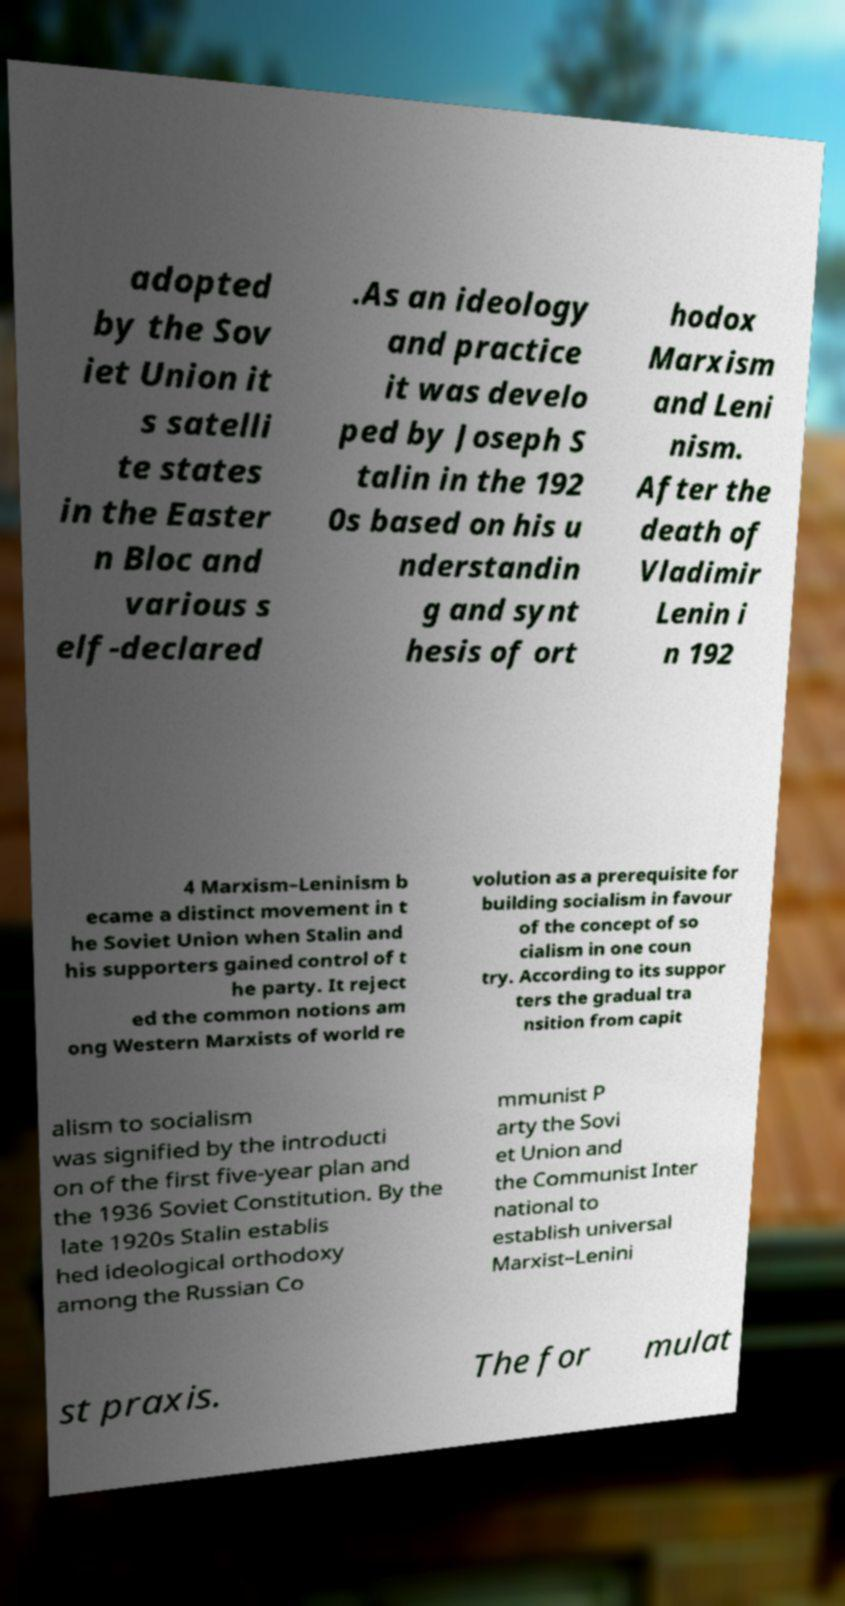Can you read and provide the text displayed in the image?This photo seems to have some interesting text. Can you extract and type it out for me? adopted by the Sov iet Union it s satelli te states in the Easter n Bloc and various s elf-declared .As an ideology and practice it was develo ped by Joseph S talin in the 192 0s based on his u nderstandin g and synt hesis of ort hodox Marxism and Leni nism. After the death of Vladimir Lenin i n 192 4 Marxism–Leninism b ecame a distinct movement in t he Soviet Union when Stalin and his supporters gained control of t he party. It reject ed the common notions am ong Western Marxists of world re volution as a prerequisite for building socialism in favour of the concept of so cialism in one coun try. According to its suppor ters the gradual tra nsition from capit alism to socialism was signified by the introducti on of the first five-year plan and the 1936 Soviet Constitution. By the late 1920s Stalin establis hed ideological orthodoxy among the Russian Co mmunist P arty the Sovi et Union and the Communist Inter national to establish universal Marxist–Lenini st praxis. The for mulat 